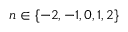<formula> <loc_0><loc_0><loc_500><loc_500>n \in \{ - 2 , - 1 , 0 , 1 , 2 \}</formula> 